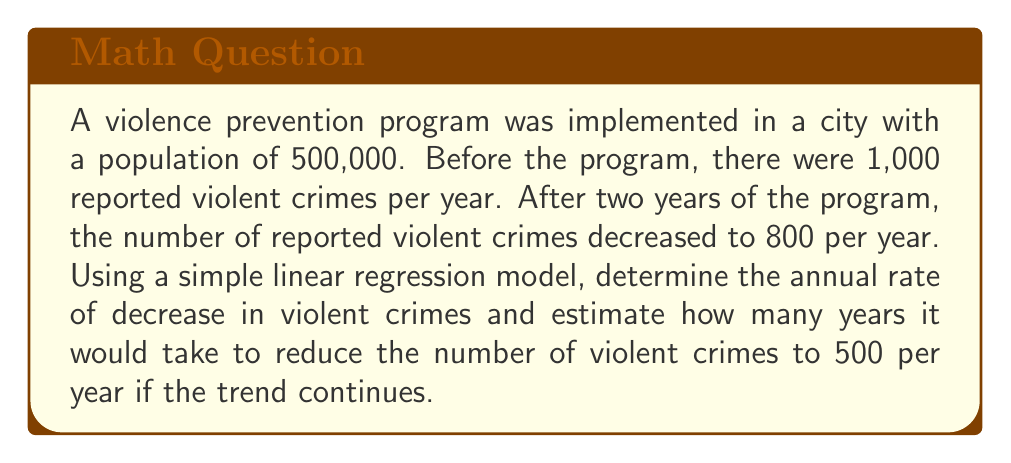Can you answer this question? Let's approach this step-by-step:

1) First, we need to calculate the rate of decrease in violent crimes per year.

   Initial number of crimes: 1000
   Number of crimes after 2 years: 800
   Total decrease: 1000 - 800 = 200
   Annual decrease: 200 / 2 = 100 crimes per year

2) We can represent this as a linear equation:
   $$y = mx + b$$
   where $y$ is the number of crimes, $m$ is the rate of decrease, $x$ is the number of years, and $b$ is the initial number of crimes.

3) Our equation becomes:
   $$y = -100x + 1000$$

4) To find how many years it would take to reach 500 crimes, we solve:
   $$500 = -100x + 1000$$

5) Rearranging the equation:
   $$-100x = -500$$
   $$x = 5$$

Therefore, it would take 5 years from the start of the program to reach 500 crimes per year if the trend continues linearly.

To verify:
Year 0: 1000 crimes
Year 1: 900 crimes
Year 2: 800 crimes
Year 3: 700 crimes
Year 4: 600 crimes
Year 5: 500 crimes
Answer: 5 years 